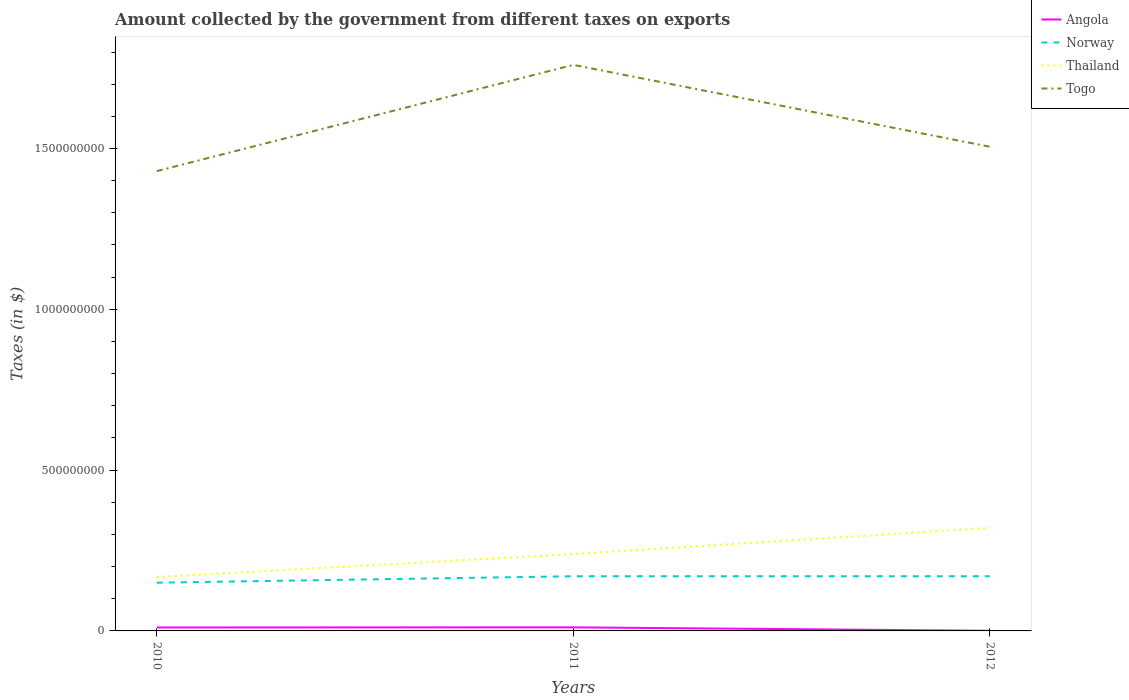How many different coloured lines are there?
Your answer should be very brief. 4. Does the line corresponding to Angola intersect with the line corresponding to Thailand?
Your response must be concise. No. Is the number of lines equal to the number of legend labels?
Keep it short and to the point. Yes. Across all years, what is the maximum amount collected by the government from taxes on exports in Togo?
Provide a short and direct response. 1.43e+09. What is the total amount collected by the government from taxes on exports in Norway in the graph?
Ensure brevity in your answer.  -2.00e+07. What is the difference between the highest and the second highest amount collected by the government from taxes on exports in Togo?
Offer a terse response. 3.30e+08. What is the difference between the highest and the lowest amount collected by the government from taxes on exports in Norway?
Your answer should be very brief. 2. Is the amount collected by the government from taxes on exports in Togo strictly greater than the amount collected by the government from taxes on exports in Norway over the years?
Ensure brevity in your answer.  No. Does the graph contain any zero values?
Make the answer very short. No. How many legend labels are there?
Your answer should be very brief. 4. How are the legend labels stacked?
Give a very brief answer. Vertical. What is the title of the graph?
Provide a short and direct response. Amount collected by the government from different taxes on exports. What is the label or title of the Y-axis?
Make the answer very short. Taxes (in $). What is the Taxes (in $) in Angola in 2010?
Keep it short and to the point. 1.07e+07. What is the Taxes (in $) of Norway in 2010?
Give a very brief answer. 1.50e+08. What is the Taxes (in $) of Thailand in 2010?
Offer a very short reply. 1.68e+08. What is the Taxes (in $) of Togo in 2010?
Keep it short and to the point. 1.43e+09. What is the Taxes (in $) in Angola in 2011?
Keep it short and to the point. 1.11e+07. What is the Taxes (in $) in Norway in 2011?
Offer a terse response. 1.70e+08. What is the Taxes (in $) in Thailand in 2011?
Your answer should be very brief. 2.39e+08. What is the Taxes (in $) of Togo in 2011?
Give a very brief answer. 1.76e+09. What is the Taxes (in $) of Angola in 2012?
Offer a very short reply. 4.42e+05. What is the Taxes (in $) of Norway in 2012?
Make the answer very short. 1.70e+08. What is the Taxes (in $) of Thailand in 2012?
Your answer should be very brief. 3.21e+08. What is the Taxes (in $) of Togo in 2012?
Keep it short and to the point. 1.51e+09. Across all years, what is the maximum Taxes (in $) in Angola?
Your response must be concise. 1.11e+07. Across all years, what is the maximum Taxes (in $) of Norway?
Provide a succinct answer. 1.70e+08. Across all years, what is the maximum Taxes (in $) of Thailand?
Your answer should be very brief. 3.21e+08. Across all years, what is the maximum Taxes (in $) in Togo?
Your answer should be compact. 1.76e+09. Across all years, what is the minimum Taxes (in $) of Angola?
Your answer should be very brief. 4.42e+05. Across all years, what is the minimum Taxes (in $) in Norway?
Your answer should be very brief. 1.50e+08. Across all years, what is the minimum Taxes (in $) of Thailand?
Your answer should be very brief. 1.68e+08. Across all years, what is the minimum Taxes (in $) of Togo?
Ensure brevity in your answer.  1.43e+09. What is the total Taxes (in $) of Angola in the graph?
Give a very brief answer. 2.23e+07. What is the total Taxes (in $) of Norway in the graph?
Keep it short and to the point. 4.90e+08. What is the total Taxes (in $) in Thailand in the graph?
Your response must be concise. 7.27e+08. What is the total Taxes (in $) in Togo in the graph?
Your answer should be compact. 4.70e+09. What is the difference between the Taxes (in $) of Angola in 2010 and that in 2011?
Make the answer very short. -4.03e+05. What is the difference between the Taxes (in $) of Norway in 2010 and that in 2011?
Make the answer very short. -2.00e+07. What is the difference between the Taxes (in $) in Thailand in 2010 and that in 2011?
Offer a terse response. -7.14e+07. What is the difference between the Taxes (in $) in Togo in 2010 and that in 2011?
Provide a succinct answer. -3.30e+08. What is the difference between the Taxes (in $) in Angola in 2010 and that in 2012?
Offer a terse response. 1.03e+07. What is the difference between the Taxes (in $) of Norway in 2010 and that in 2012?
Provide a short and direct response. -2.00e+07. What is the difference between the Taxes (in $) in Thailand in 2010 and that in 2012?
Your answer should be very brief. -1.53e+08. What is the difference between the Taxes (in $) in Togo in 2010 and that in 2012?
Ensure brevity in your answer.  -7.58e+07. What is the difference between the Taxes (in $) of Angola in 2011 and that in 2012?
Ensure brevity in your answer.  1.07e+07. What is the difference between the Taxes (in $) of Norway in 2011 and that in 2012?
Offer a terse response. 0. What is the difference between the Taxes (in $) in Thailand in 2011 and that in 2012?
Your answer should be compact. -8.16e+07. What is the difference between the Taxes (in $) in Togo in 2011 and that in 2012?
Keep it short and to the point. 2.54e+08. What is the difference between the Taxes (in $) of Angola in 2010 and the Taxes (in $) of Norway in 2011?
Give a very brief answer. -1.59e+08. What is the difference between the Taxes (in $) in Angola in 2010 and the Taxes (in $) in Thailand in 2011?
Offer a very short reply. -2.28e+08. What is the difference between the Taxes (in $) of Angola in 2010 and the Taxes (in $) of Togo in 2011?
Offer a terse response. -1.75e+09. What is the difference between the Taxes (in $) in Norway in 2010 and the Taxes (in $) in Thailand in 2011?
Offer a terse response. -8.89e+07. What is the difference between the Taxes (in $) of Norway in 2010 and the Taxes (in $) of Togo in 2011?
Provide a succinct answer. -1.61e+09. What is the difference between the Taxes (in $) of Thailand in 2010 and the Taxes (in $) of Togo in 2011?
Give a very brief answer. -1.59e+09. What is the difference between the Taxes (in $) in Angola in 2010 and the Taxes (in $) in Norway in 2012?
Offer a terse response. -1.59e+08. What is the difference between the Taxes (in $) in Angola in 2010 and the Taxes (in $) in Thailand in 2012?
Provide a short and direct response. -3.10e+08. What is the difference between the Taxes (in $) of Angola in 2010 and the Taxes (in $) of Togo in 2012?
Offer a terse response. -1.49e+09. What is the difference between the Taxes (in $) in Norway in 2010 and the Taxes (in $) in Thailand in 2012?
Make the answer very short. -1.71e+08. What is the difference between the Taxes (in $) in Norway in 2010 and the Taxes (in $) in Togo in 2012?
Make the answer very short. -1.36e+09. What is the difference between the Taxes (in $) of Thailand in 2010 and the Taxes (in $) of Togo in 2012?
Give a very brief answer. -1.34e+09. What is the difference between the Taxes (in $) in Angola in 2011 and the Taxes (in $) in Norway in 2012?
Offer a very short reply. -1.59e+08. What is the difference between the Taxes (in $) in Angola in 2011 and the Taxes (in $) in Thailand in 2012?
Keep it short and to the point. -3.09e+08. What is the difference between the Taxes (in $) of Angola in 2011 and the Taxes (in $) of Togo in 2012?
Keep it short and to the point. -1.49e+09. What is the difference between the Taxes (in $) in Norway in 2011 and the Taxes (in $) in Thailand in 2012?
Offer a very short reply. -1.51e+08. What is the difference between the Taxes (in $) in Norway in 2011 and the Taxes (in $) in Togo in 2012?
Ensure brevity in your answer.  -1.34e+09. What is the difference between the Taxes (in $) of Thailand in 2011 and the Taxes (in $) of Togo in 2012?
Offer a very short reply. -1.27e+09. What is the average Taxes (in $) of Angola per year?
Offer a terse response. 7.43e+06. What is the average Taxes (in $) of Norway per year?
Keep it short and to the point. 1.63e+08. What is the average Taxes (in $) of Thailand per year?
Your answer should be compact. 2.42e+08. What is the average Taxes (in $) in Togo per year?
Ensure brevity in your answer.  1.57e+09. In the year 2010, what is the difference between the Taxes (in $) of Angola and Taxes (in $) of Norway?
Give a very brief answer. -1.39e+08. In the year 2010, what is the difference between the Taxes (in $) in Angola and Taxes (in $) in Thailand?
Offer a very short reply. -1.57e+08. In the year 2010, what is the difference between the Taxes (in $) of Angola and Taxes (in $) of Togo?
Ensure brevity in your answer.  -1.42e+09. In the year 2010, what is the difference between the Taxes (in $) of Norway and Taxes (in $) of Thailand?
Give a very brief answer. -1.75e+07. In the year 2010, what is the difference between the Taxes (in $) in Norway and Taxes (in $) in Togo?
Your response must be concise. -1.28e+09. In the year 2010, what is the difference between the Taxes (in $) of Thailand and Taxes (in $) of Togo?
Make the answer very short. -1.26e+09. In the year 2011, what is the difference between the Taxes (in $) of Angola and Taxes (in $) of Norway?
Provide a succinct answer. -1.59e+08. In the year 2011, what is the difference between the Taxes (in $) in Angola and Taxes (in $) in Thailand?
Make the answer very short. -2.28e+08. In the year 2011, what is the difference between the Taxes (in $) in Angola and Taxes (in $) in Togo?
Offer a very short reply. -1.75e+09. In the year 2011, what is the difference between the Taxes (in $) of Norway and Taxes (in $) of Thailand?
Ensure brevity in your answer.  -6.89e+07. In the year 2011, what is the difference between the Taxes (in $) in Norway and Taxes (in $) in Togo?
Provide a short and direct response. -1.59e+09. In the year 2011, what is the difference between the Taxes (in $) in Thailand and Taxes (in $) in Togo?
Give a very brief answer. -1.52e+09. In the year 2012, what is the difference between the Taxes (in $) in Angola and Taxes (in $) in Norway?
Offer a terse response. -1.70e+08. In the year 2012, what is the difference between the Taxes (in $) in Angola and Taxes (in $) in Thailand?
Provide a short and direct response. -3.20e+08. In the year 2012, what is the difference between the Taxes (in $) in Angola and Taxes (in $) in Togo?
Your answer should be very brief. -1.51e+09. In the year 2012, what is the difference between the Taxes (in $) of Norway and Taxes (in $) of Thailand?
Make the answer very short. -1.51e+08. In the year 2012, what is the difference between the Taxes (in $) of Norway and Taxes (in $) of Togo?
Provide a short and direct response. -1.34e+09. In the year 2012, what is the difference between the Taxes (in $) in Thailand and Taxes (in $) in Togo?
Make the answer very short. -1.18e+09. What is the ratio of the Taxes (in $) of Angola in 2010 to that in 2011?
Provide a succinct answer. 0.96. What is the ratio of the Taxes (in $) in Norway in 2010 to that in 2011?
Provide a short and direct response. 0.88. What is the ratio of the Taxes (in $) in Thailand in 2010 to that in 2011?
Provide a short and direct response. 0.7. What is the ratio of the Taxes (in $) in Togo in 2010 to that in 2011?
Your response must be concise. 0.81. What is the ratio of the Taxes (in $) in Angola in 2010 to that in 2012?
Your answer should be very brief. 24.23. What is the ratio of the Taxes (in $) of Norway in 2010 to that in 2012?
Offer a very short reply. 0.88. What is the ratio of the Taxes (in $) in Thailand in 2010 to that in 2012?
Your answer should be very brief. 0.52. What is the ratio of the Taxes (in $) of Togo in 2010 to that in 2012?
Your response must be concise. 0.95. What is the ratio of the Taxes (in $) of Angola in 2011 to that in 2012?
Give a very brief answer. 25.14. What is the ratio of the Taxes (in $) in Thailand in 2011 to that in 2012?
Offer a very short reply. 0.75. What is the ratio of the Taxes (in $) in Togo in 2011 to that in 2012?
Your response must be concise. 1.17. What is the difference between the highest and the second highest Taxes (in $) in Angola?
Give a very brief answer. 4.03e+05. What is the difference between the highest and the second highest Taxes (in $) in Thailand?
Offer a terse response. 8.16e+07. What is the difference between the highest and the second highest Taxes (in $) in Togo?
Your answer should be compact. 2.54e+08. What is the difference between the highest and the lowest Taxes (in $) in Angola?
Provide a succinct answer. 1.07e+07. What is the difference between the highest and the lowest Taxes (in $) in Norway?
Ensure brevity in your answer.  2.00e+07. What is the difference between the highest and the lowest Taxes (in $) in Thailand?
Provide a succinct answer. 1.53e+08. What is the difference between the highest and the lowest Taxes (in $) of Togo?
Provide a short and direct response. 3.30e+08. 